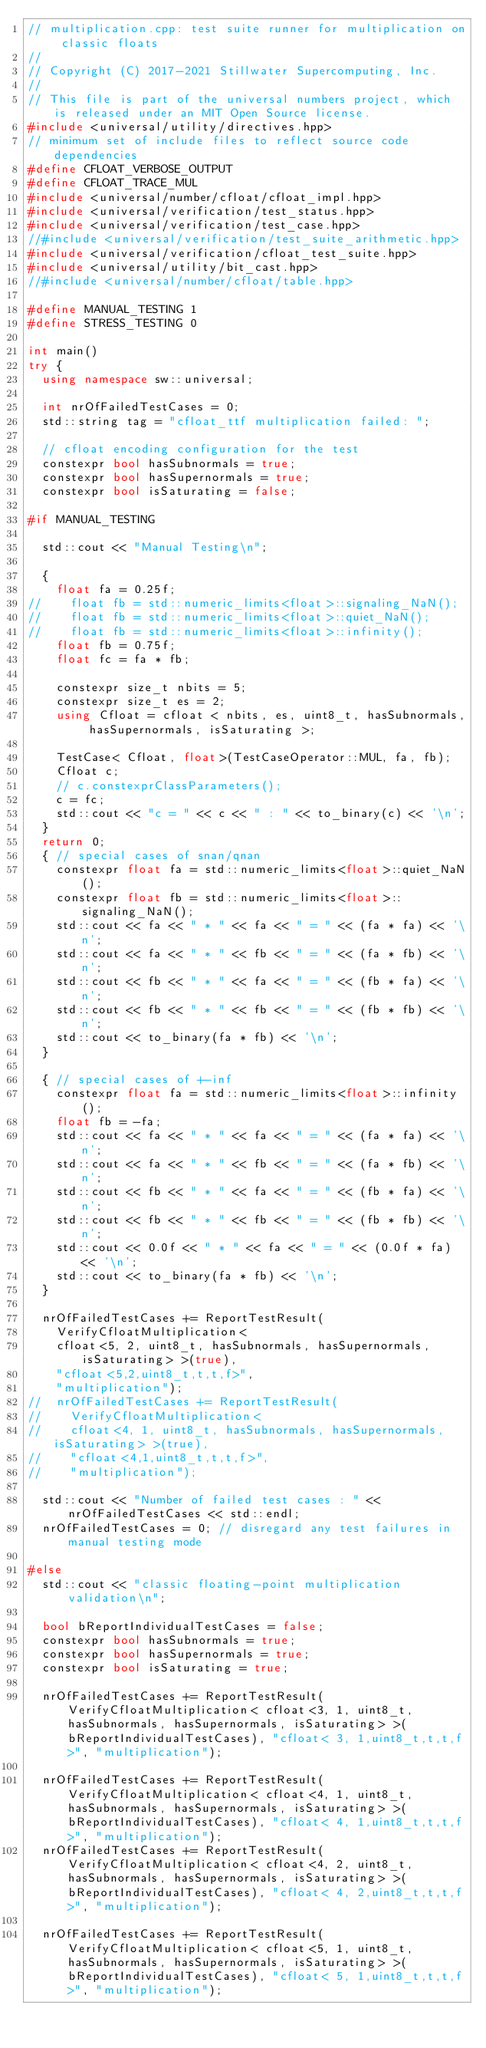Convert code to text. <code><loc_0><loc_0><loc_500><loc_500><_C++_>// multiplication.cpp: test suite runner for multiplication on classic floats
//
// Copyright (C) 2017-2021 Stillwater Supercomputing, Inc.
//
// This file is part of the universal numbers project, which is released under an MIT Open Source license.
#include <universal/utility/directives.hpp>
// minimum set of include files to reflect source code dependencies
#define CFLOAT_VERBOSE_OUTPUT
#define CFLOAT_TRACE_MUL
#include <universal/number/cfloat/cfloat_impl.hpp>
#include <universal/verification/test_status.hpp>
#include <universal/verification/test_case.hpp>
//#include <universal/verification/test_suite_arithmetic.hpp>
#include <universal/verification/cfloat_test_suite.hpp>
#include <universal/utility/bit_cast.hpp>
//#include <universal/number/cfloat/table.hpp>

#define MANUAL_TESTING 1
#define STRESS_TESTING 0

int main()
try {
	using namespace sw::universal;

	int nrOfFailedTestCases = 0;
	std::string tag = "cfloat_ttf multiplication failed: ";

	// cfloat encoding configuration for the test
	constexpr bool hasSubnormals = true;
	constexpr bool hasSupernormals = true;
	constexpr bool isSaturating = false;

#if MANUAL_TESTING

	std::cout << "Manual Testing\n";

	{
		float fa = 0.25f; 
//		float fb = std::numeric_limits<float>::signaling_NaN();
//		float fb = std::numeric_limits<float>::quiet_NaN();
//		float fb = std::numeric_limits<float>::infinity();
		float fb = 0.75f;
		float fc = fa * fb;

		constexpr size_t nbits = 5;
		constexpr size_t es = 2;
		using Cfloat = cfloat < nbits, es, uint8_t, hasSubnormals, hasSupernormals, isSaturating >;

		TestCase< Cfloat, float>(TestCaseOperator::MUL, fa, fb);
		Cfloat c; 
		// c.constexprClassParameters();
		c = fc;
		std::cout << "c = " << c << " : " << to_binary(c) << '\n';
	}
	return 0;
	{ // special cases of snan/qnan
		constexpr float fa = std::numeric_limits<float>::quiet_NaN();
		constexpr float fb = std::numeric_limits<float>::signaling_NaN();
		std::cout << fa << " * " << fa << " = " << (fa * fa) << '\n';
		std::cout << fa << " * " << fb << " = " << (fa * fb) << '\n';
		std::cout << fb << " * " << fa << " = " << (fb * fa) << '\n';
		std::cout << fb << " * " << fb << " = " << (fb * fb) << '\n';
		std::cout << to_binary(fa * fb) << '\n';
	}

	{ // special cases of +-inf
		constexpr float fa = std::numeric_limits<float>::infinity();
		float fb = -fa;
		std::cout << fa << " * " << fa << " = " << (fa * fa) << '\n';
		std::cout << fa << " * " << fb << " = " << (fa * fb) << '\n';
		std::cout << fb << " * " << fa << " = " << (fb * fa) << '\n';
		std::cout << fb << " * " << fb << " = " << (fb * fb) << '\n';
		std::cout << 0.0f << " * " << fa << " = " << (0.0f * fa) << '\n';
		std::cout << to_binary(fa * fb) << '\n';
	}

	nrOfFailedTestCases += ReportTestResult(
		VerifyCfloatMultiplication< 
		cfloat<5, 2, uint8_t, hasSubnormals, hasSupernormals, isSaturating> >(true), 
		"cfloat<5,2,uint8_t,t,t,f>", 
		"multiplication");
//	nrOfFailedTestCases += ReportTestResult(
//		VerifyCfloatMultiplication<
//		cfloat<4, 1, uint8_t, hasSubnormals, hasSupernormals, isSaturating> >(true),
//		"cfloat<4,1,uint8_t,t,t,f>",
//		"multiplication");

	std::cout << "Number of failed test cases : " << nrOfFailedTestCases << std::endl;
	nrOfFailedTestCases = 0; // disregard any test failures in manual testing mode

#else
	std::cout << "classic floating-point multiplication validation\n";

	bool bReportIndividualTestCases = false;
	constexpr bool hasSubnormals = true;
	constexpr bool hasSupernormals = true;
	constexpr bool isSaturating = true;

	nrOfFailedTestCases += ReportTestResult(VerifyCfloatMultiplication< cfloat<3, 1, uint8_t, hasSubnormals, hasSupernormals, isSaturating> >(bReportIndividualTestCases), "cfloat< 3, 1,uint8_t,t,t,f>", "multiplication");

	nrOfFailedTestCases += ReportTestResult(VerifyCfloatMultiplication< cfloat<4, 1, uint8_t, hasSubnormals, hasSupernormals, isSaturating> >(bReportIndividualTestCases), "cfloat< 4, 1,uint8_t,t,t,f>", "multiplication");
	nrOfFailedTestCases += ReportTestResult(VerifyCfloatMultiplication< cfloat<4, 2, uint8_t, hasSubnormals, hasSupernormals, isSaturating> >(bReportIndividualTestCases), "cfloat< 4, 2,uint8_t,t,t,f>", "multiplication");

	nrOfFailedTestCases += ReportTestResult(VerifyCfloatMultiplication< cfloat<5, 1, uint8_t, hasSubnormals, hasSupernormals, isSaturating> >(bReportIndividualTestCases), "cfloat< 5, 1,uint8_t,t,t,f>", "multiplication");</code> 